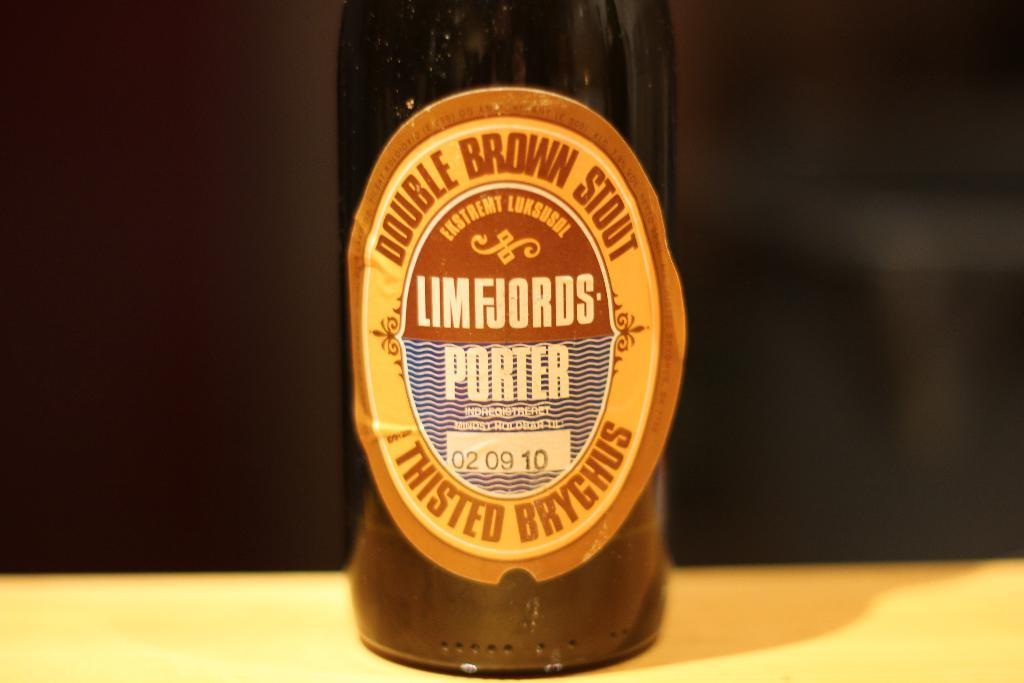<image>
Offer a succinct explanation of the picture presented. A bottle of Limfjords Porter Stout Ale sits on a table. 